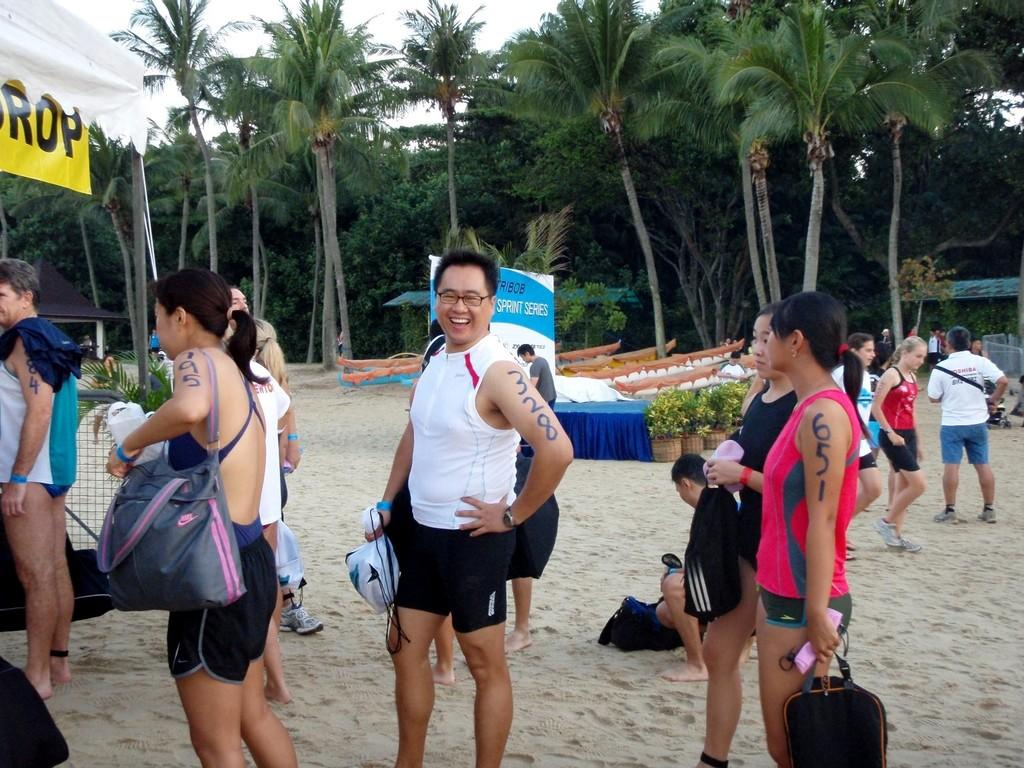What is the main focus of the image? The main focus of the image is the people in the center. What can be seen in the background of the image? There are trees in the background of the image. What type of yarn is being used by the people in the image? There is no yarn present in the image; it features people and trees in the background. What are the boys in the image writing on the trees? There are no boys or writing present in the image. 